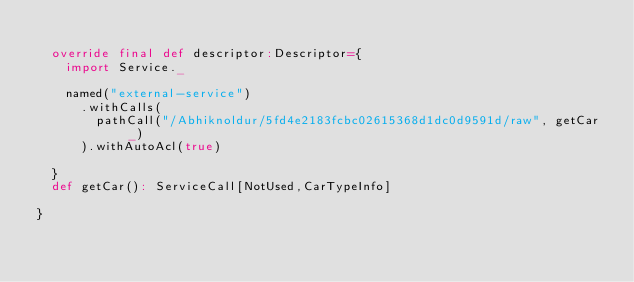<code> <loc_0><loc_0><loc_500><loc_500><_Scala_>
  override final def descriptor:Descriptor={
    import Service._

    named("external-service")
      .withCalls(
        pathCall("/Abhiknoldur/5fd4e2183fcbc02615368d1dc0d9591d/raw", getCar _)
      ).withAutoAcl(true)

  }
  def getCar(): ServiceCall[NotUsed,CarTypeInfo]

}
</code> 